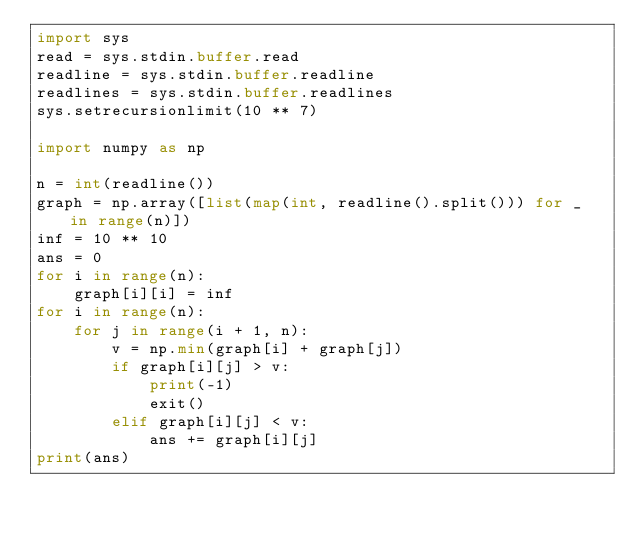Convert code to text. <code><loc_0><loc_0><loc_500><loc_500><_Python_>import sys
read = sys.stdin.buffer.read
readline = sys.stdin.buffer.readline
readlines = sys.stdin.buffer.readlines
sys.setrecursionlimit(10 ** 7)

import numpy as np

n = int(readline())
graph = np.array([list(map(int, readline().split())) for _ in range(n)])
inf = 10 ** 10
ans = 0
for i in range(n):
    graph[i][i] = inf
for i in range(n):
    for j in range(i + 1, n):
        v = np.min(graph[i] + graph[j])
        if graph[i][j] > v:
            print(-1)
            exit()
        elif graph[i][j] < v:
            ans += graph[i][j]
print(ans)
</code> 